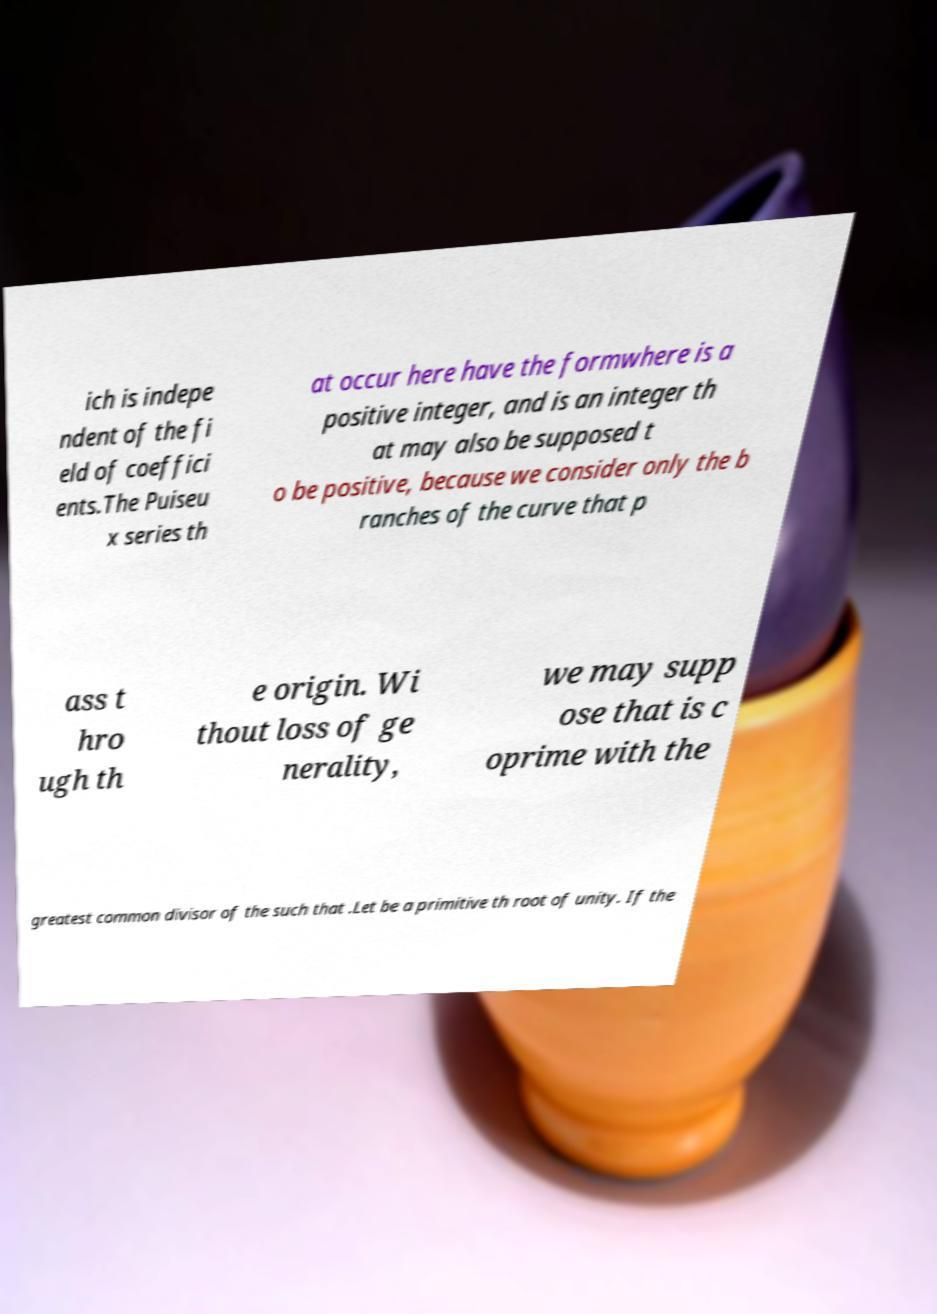Could you assist in decoding the text presented in this image and type it out clearly? ich is indepe ndent of the fi eld of coeffici ents.The Puiseu x series th at occur here have the formwhere is a positive integer, and is an integer th at may also be supposed t o be positive, because we consider only the b ranches of the curve that p ass t hro ugh th e origin. Wi thout loss of ge nerality, we may supp ose that is c oprime with the greatest common divisor of the such that .Let be a primitive th root of unity. If the 